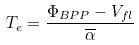Convert formula to latex. <formula><loc_0><loc_0><loc_500><loc_500>T _ { e } = \frac { \Phi _ { B P P } - V _ { f l } } { \overline { \alpha } }</formula> 